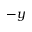<formula> <loc_0><loc_0><loc_500><loc_500>- y</formula> 